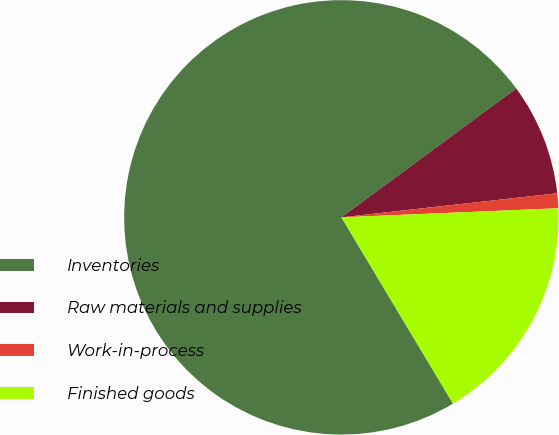Convert chart. <chart><loc_0><loc_0><loc_500><loc_500><pie_chart><fcel>Inventories<fcel>Raw materials and supplies<fcel>Work-in-process<fcel>Finished goods<nl><fcel>73.48%<fcel>8.34%<fcel>1.1%<fcel>17.07%<nl></chart> 